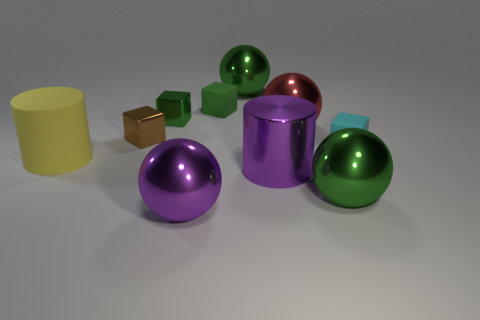What number of big objects have the same color as the big metal cylinder? 1 